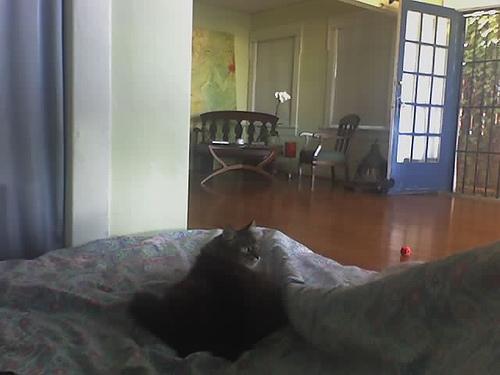The animal is resting on what?
Choose the correct response and explain in the format: 'Answer: answer
Rationale: rationale.'
Options: Owner's head, chair, tub, blanket. Answer: blanket.
Rationale: The animal is on a blanket. 